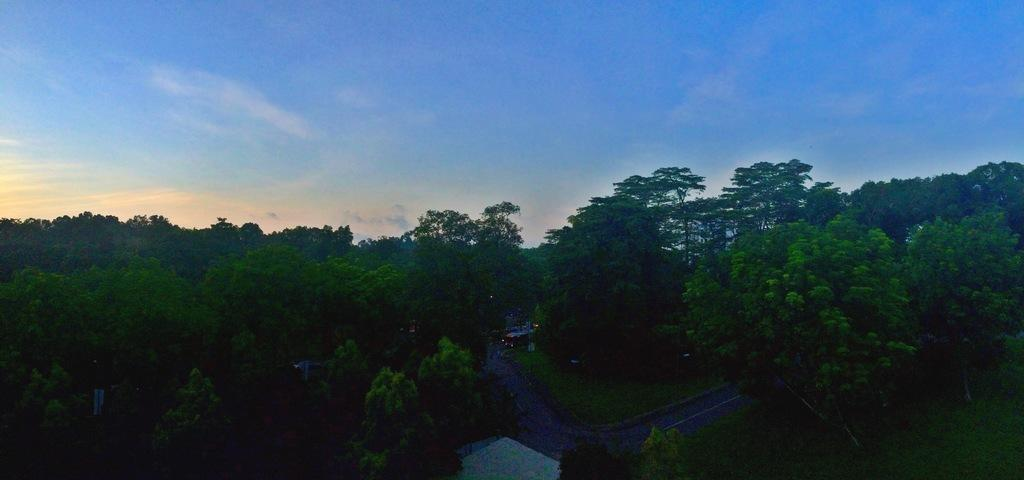What is located at the bottom of the picture? There is a road at the bottom of the picture. What type of vegetation can be seen on either side of the picture? There are trees on either side of the picture. What is visible at the top of the picture? The sky is visible at the top of the picture. What color is the sky in the picture? The color of the sky is blue. How many birds are sitting on the appliance in the picture? There are no birds or appliances present in the picture. What type of seed can be seen growing near the trees in the picture? There is no mention of seeds or any plant life other than trees in the provided facts. 